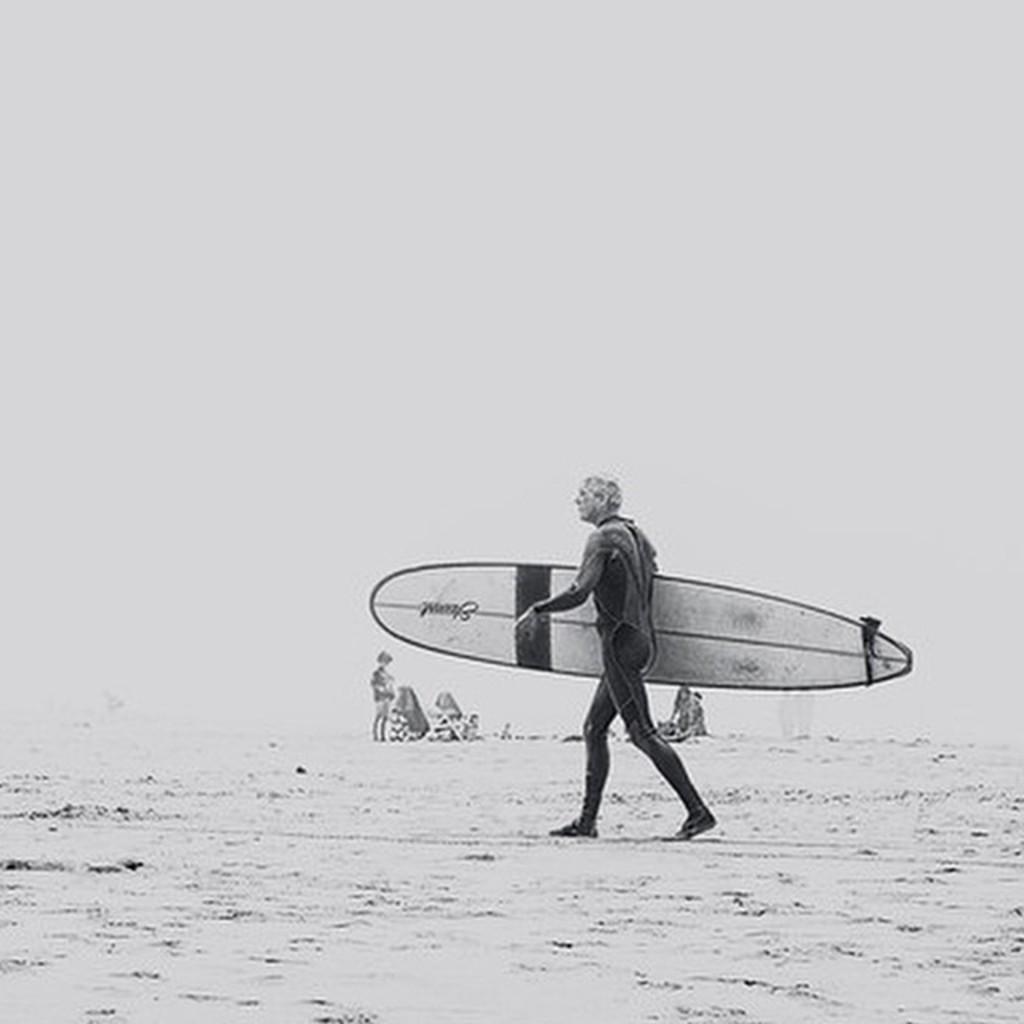Describe this image in one or two sentences. In the image we can see there is a person who is standing and holding a surfing board in his hand and on the other side there are people who are sitting and standing on the sand. The image is in black and white colour. 